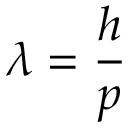<formula> <loc_0><loc_0><loc_500><loc_500>\lambda = { \frac { h } { p } }</formula> 